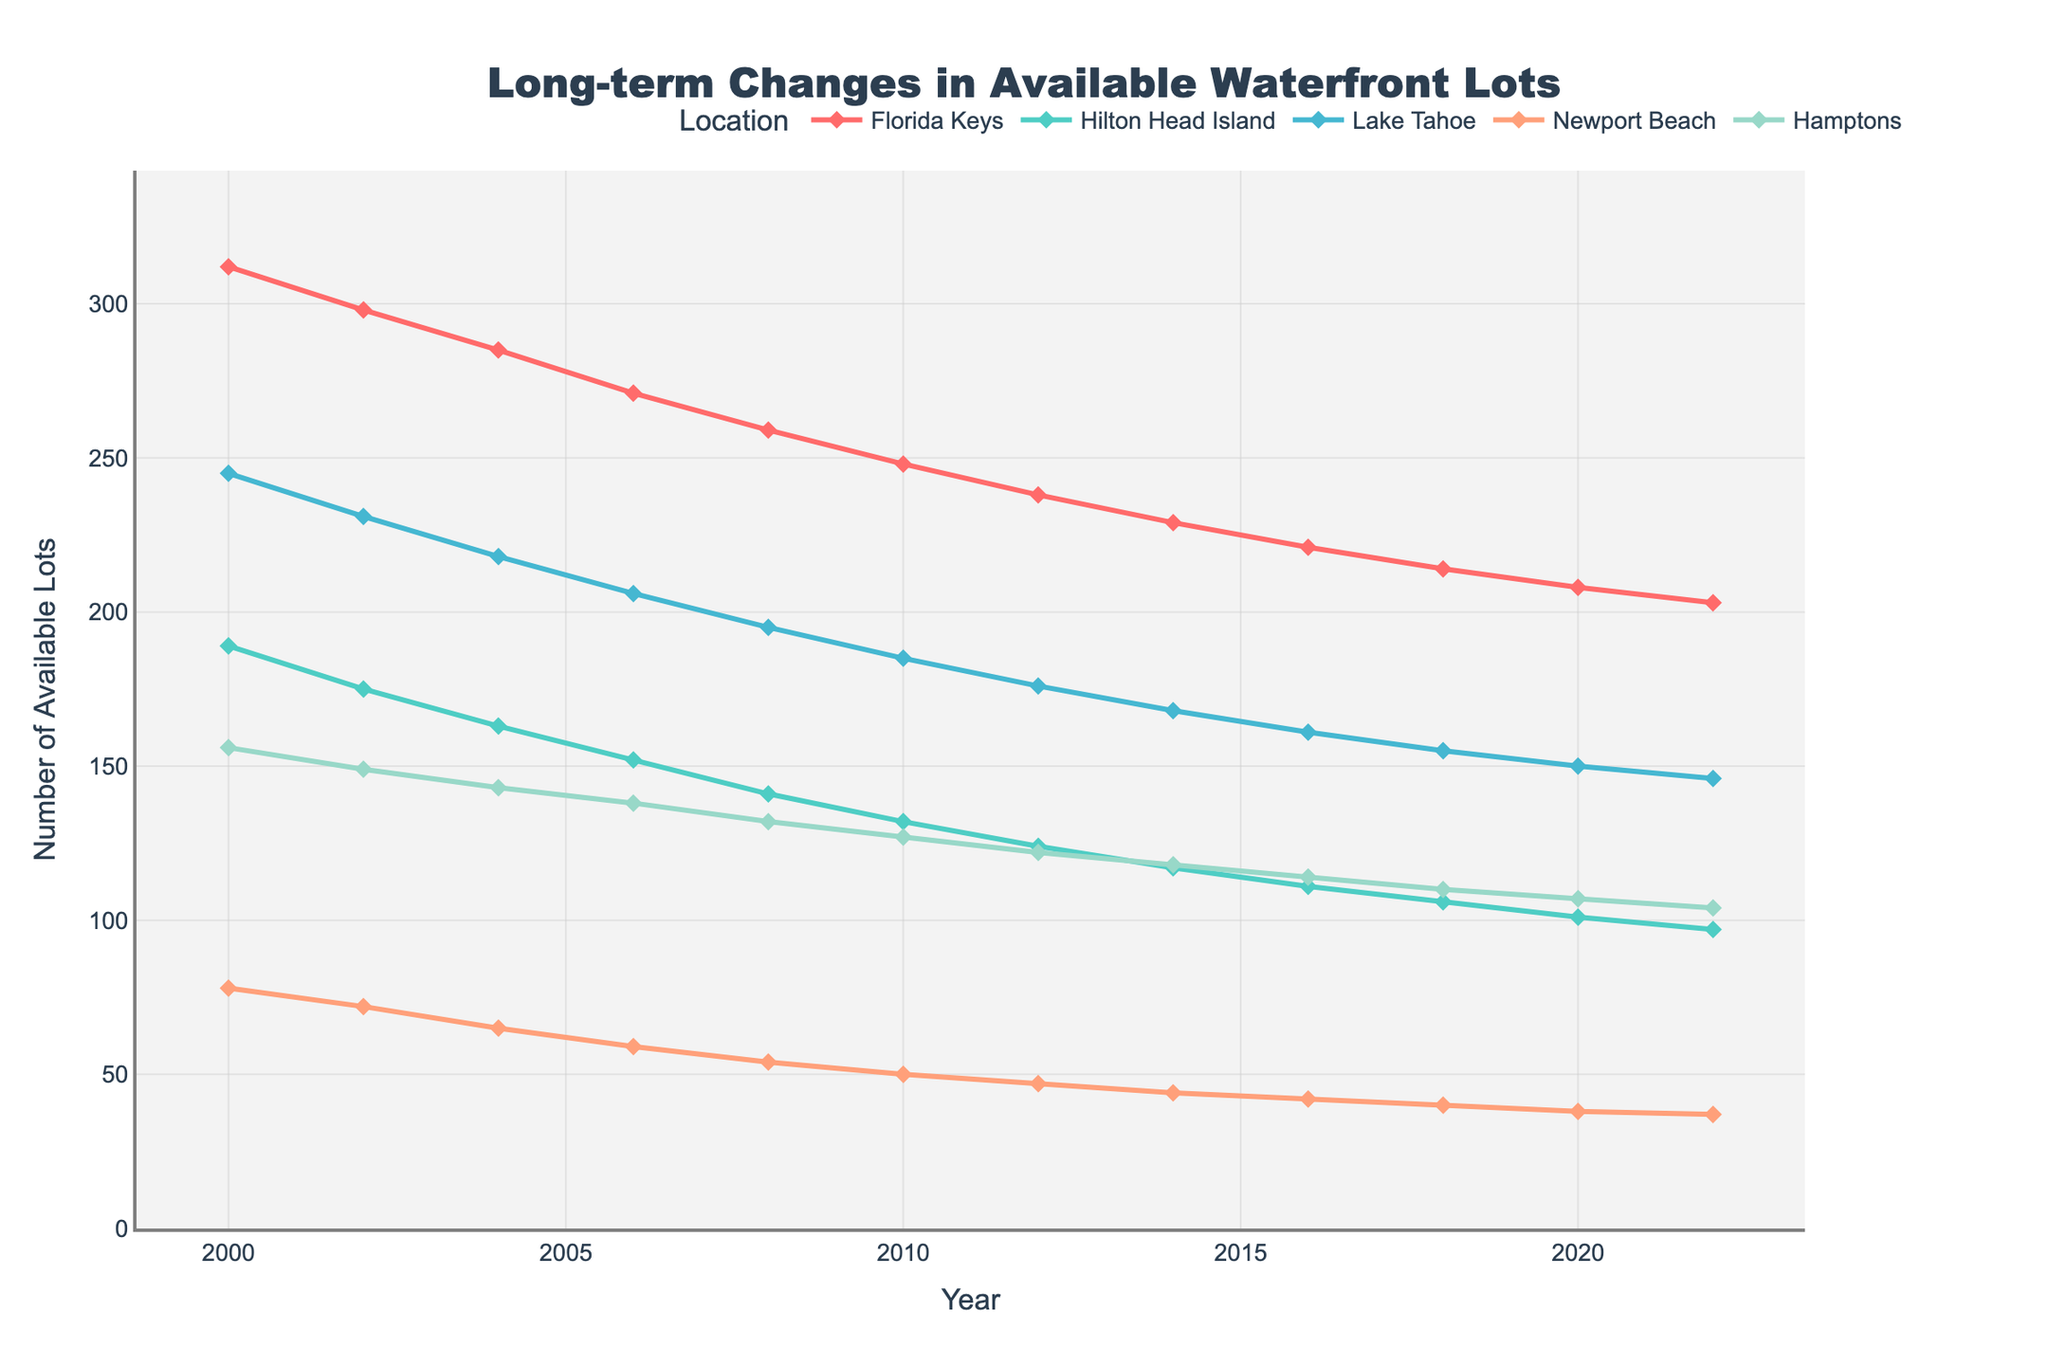How has the number of available waterfront lots in the Florida Keys changed from 2000 to 2022? The figure shows a line representing the Florida Keys, starting at 312 lots in 2000 and ending at 203 lots in 2022. The line consistently trends downward over the entire period.
Answer: The number of available waterfront lots in the Florida Keys decreased from 312 to 203 Which location experienced the greatest decrease in available lots from 2010 to 2022? To determine the location with the greatest decrease, subtract the 2022 value from the 2010 value for each location and compare the differences. The Florida Keys decreased from 248 to 203 (45 lots), Hilton Head Island from 132 to 97 (35 lots), Lake Tahoe from 185 to 146 (39 lots), Newport Beach from 50 to 37 (13 lots), and the Hamptons from 127 to 104 (23 lots). The Florida Keys experienced the greatest decrease.
Answer: The Florida Keys What is the total number of available lots in all locations combined in the year 2006? Add up the number of available lots for each location in the year 2006: 271 (Florida Keys) + 152 (Hilton Head Island) + 206 (Lake Tahoe) + 59 (Newport Beach) + 138 (Hamptons) = 826
Answer: 826 By how many lots did the available lots in Newport Beach decrease between 2004 and 2014? To find the decrease, subtract the 2014 value from the 2004 value for Newport Beach: 65 (2004) - 44 (2014) = 21
Answer: 21 Between 2000 and 2022, which location had the most stable number of available waterfront lots, and what is the range of its lot counts? To determine stability, assess the range (difference between the maximum and minimum values) for each location. The Florida Keys range from 312 to 203 (109 lots), Hilton Head Island from 189 to 97 (92 lots), Lake Tahoe from 245 to 146 (99 lots), Newport Beach from 78 to 37 (41 lots), and the Hamptons from 156 to 104 (52 lots). Therefore, Newport Beach has the most stable number of available lots with a range of 41.
Answer: Newport Beach, 41 Which two locations had the closest number of available lots in 2022, and what were those numbers? In 2022, the numbers were: Florida Keys (203), Hilton Head Island (97), Lake Tahoe (146), Newport Beach (37), and the Hamptons (104). The closest numbers are Hilton Head Island (97) and the Hamptons (104), a difference of 7.
Answer: Hilton Head Island (97) and the Hamptons (104) What is the average decrease in the number of available waterfront lots per location from 2000 to 2022? Calculate the total decrease for each location, sum these values, and then divide by the number of locations. Florida Keys: 312 - 203 = 109, Hilton Head Island: 189 - 97 = 92, Lake Tahoe: 245 - 146 = 99, Newport Beach: 78 - 37 = 41, Hamptons: 156 - 104 = 52. The total decrease is 109 + 92 + 99 + 41 + 52 = 393. Divide by 5 locations: 393 / 5 = 78.6
Answer: 78.6 In which year did the available lots in the Hamptons drop below 150 for the first time and what was the count that year? From the figure, the Hamptons' count first dropped below 150 in 2002, when the available lots were 149.
Answer: 2002, 149 